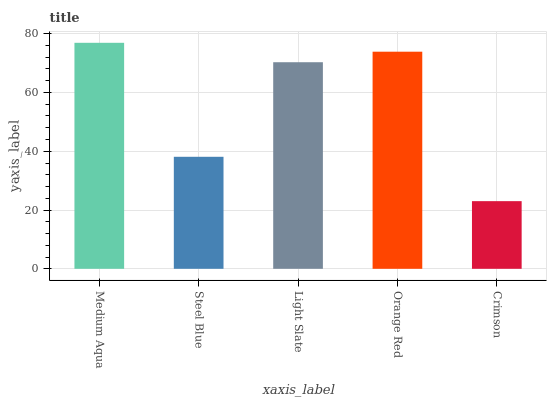Is Steel Blue the minimum?
Answer yes or no. No. Is Steel Blue the maximum?
Answer yes or no. No. Is Medium Aqua greater than Steel Blue?
Answer yes or no. Yes. Is Steel Blue less than Medium Aqua?
Answer yes or no. Yes. Is Steel Blue greater than Medium Aqua?
Answer yes or no. No. Is Medium Aqua less than Steel Blue?
Answer yes or no. No. Is Light Slate the high median?
Answer yes or no. Yes. Is Light Slate the low median?
Answer yes or no. Yes. Is Crimson the high median?
Answer yes or no. No. Is Steel Blue the low median?
Answer yes or no. No. 